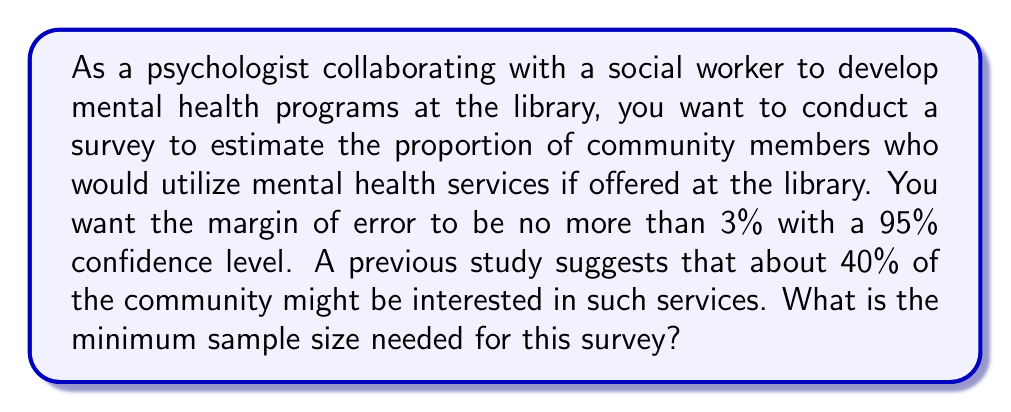Provide a solution to this math problem. To calculate the minimum sample size needed for this survey, we'll use the formula for sample size estimation for a proportion:

$$ n = \frac{z^2 \cdot p(1-p)}{E^2} $$

Where:
- $n$ is the required sample size
- $z$ is the z-score corresponding to the desired confidence level
- $p$ is the estimated proportion of the population
- $E$ is the desired margin of error

Given:
- Confidence level = 95%, which corresponds to a z-score of 1.96
- Estimated proportion $p = 0.40$ (40%)
- Desired margin of error $E = 0.03$ (3%)

Let's substitute these values into the formula:

$$ n = \frac{1.96^2 \cdot 0.40(1-0.40)}{0.03^2} $$

$$ n = \frac{3.8416 \cdot 0.40 \cdot 0.60}{0.0009} $$

$$ n = \frac{0.921984}{0.0009} $$

$$ n = 1024.4266... $$

Since we can't survey a fractional number of people, we round up to the nearest whole number.
Answer: The minimum sample size needed for the survey is 1,025 people. 